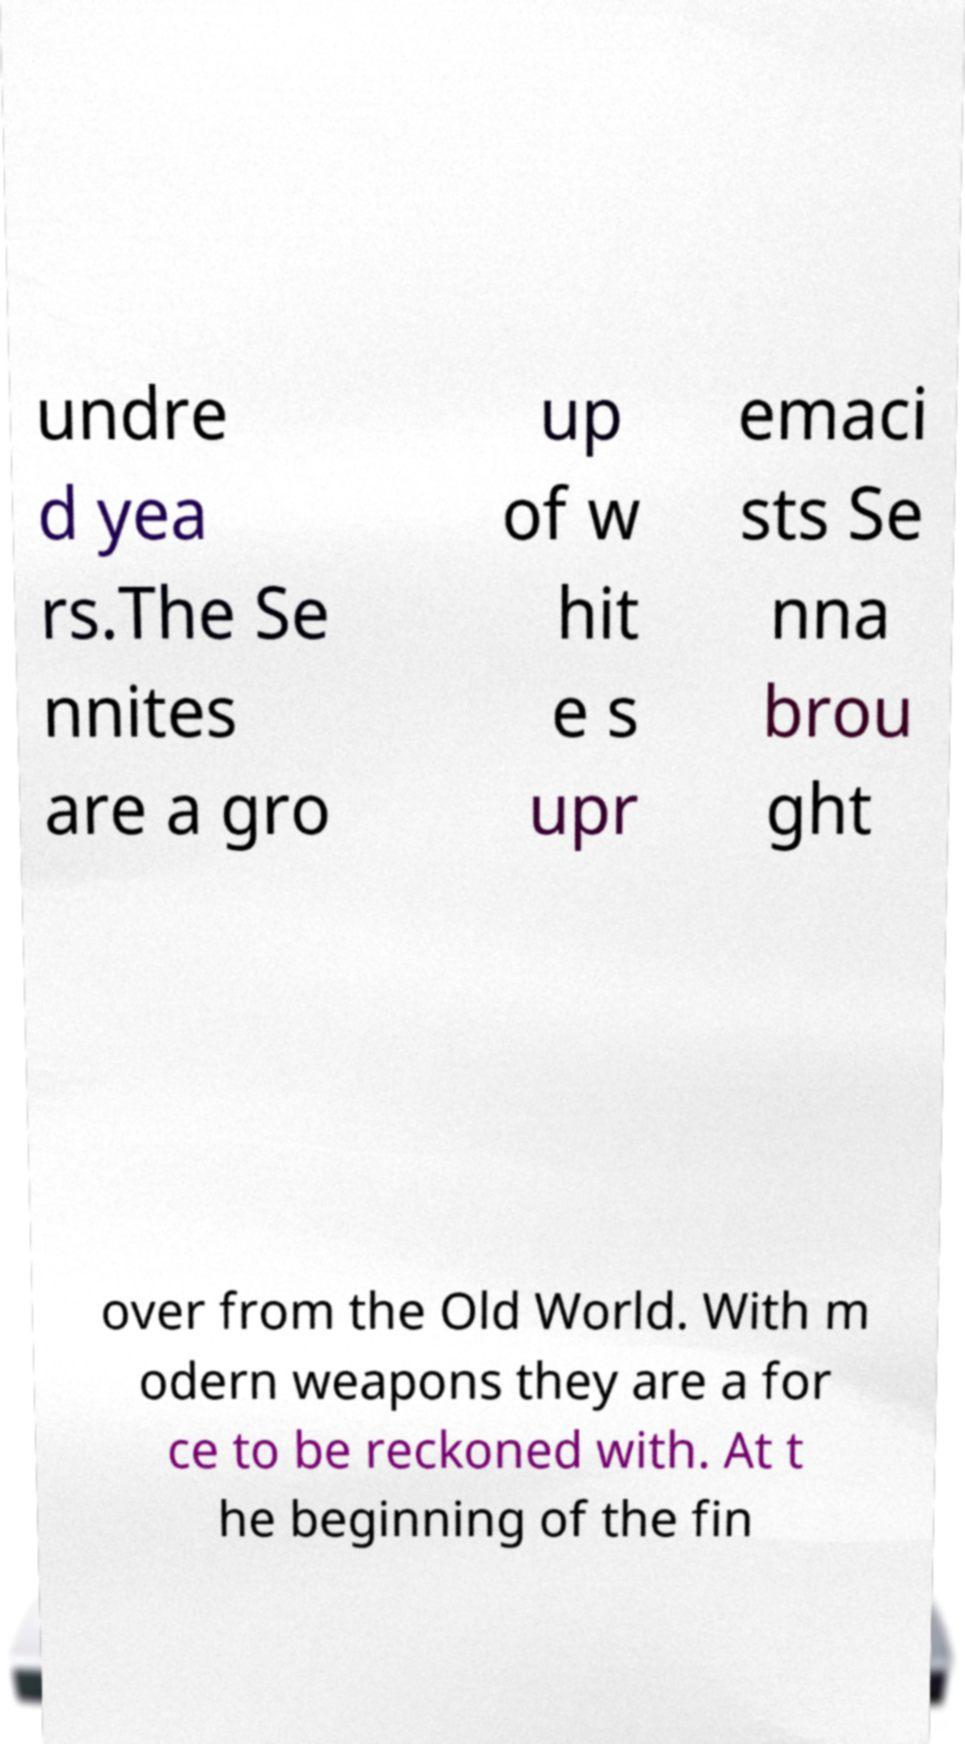I need the written content from this picture converted into text. Can you do that? undre d yea rs.The Se nnites are a gro up of w hit e s upr emaci sts Se nna brou ght over from the Old World. With m odern weapons they are a for ce to be reckoned with. At t he beginning of the fin 